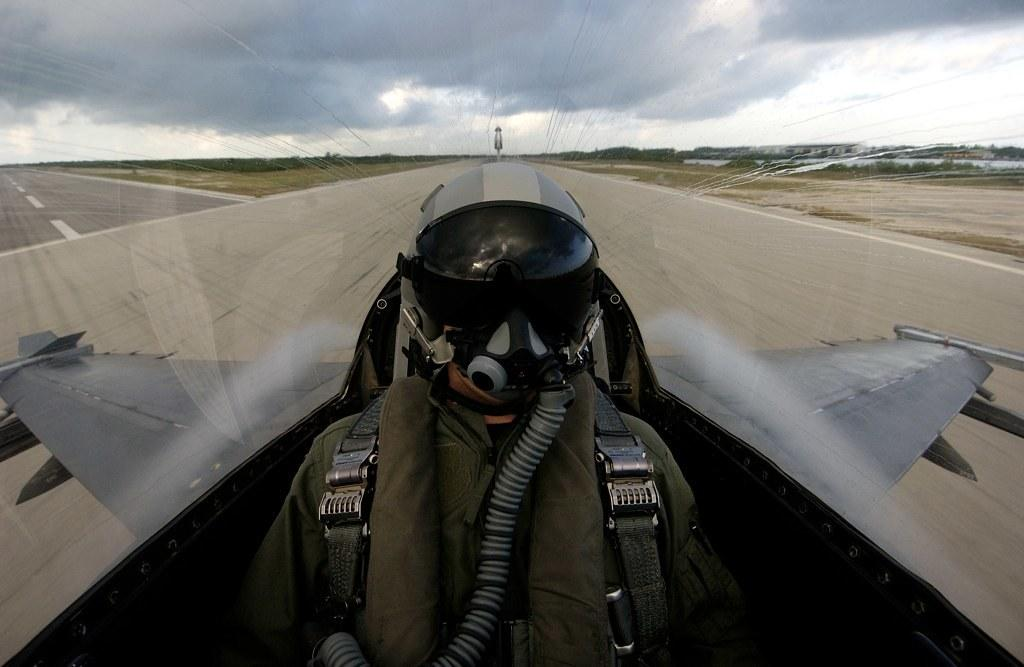Where is the person located in the image? The person is inside the airplane in the image. What is the person wearing? The person is wearing a helmet. What are the main features of the airplane? The airplane has wings. What can be seen in the background of the image? There is a road and the sky visible in the background. What is the condition of the sky in the image? Clouds are present in the sky. Can you tell me how many pieces of pie are on the table in the image? There is no table or pie present in the image; it features a person inside an airplane. What type of cave can be seen in the background of the image? There is no cave present in the image; it features a road and the sky in the background. 